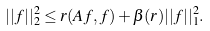Convert formula to latex. <formula><loc_0><loc_0><loc_500><loc_500>| | f | | _ { 2 } ^ { 2 } \leq r ( A f , f ) + \beta ( r ) | | f | | _ { 1 } ^ { 2 } .</formula> 